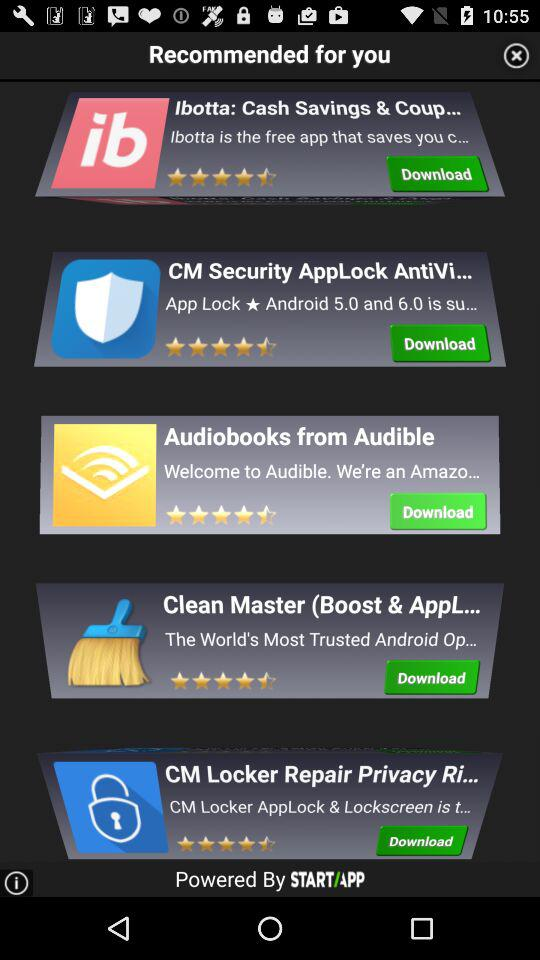What is the version of Android supported by the "CM Security AppLock AntiVirus" application? The versions of Android supported by the "CM Security AppLock AntiVirus" application are 5.0 and 6.0. 